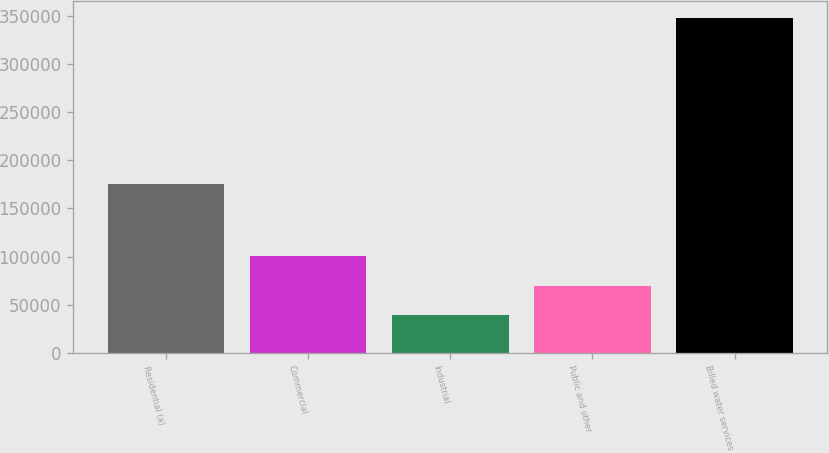<chart> <loc_0><loc_0><loc_500><loc_500><bar_chart><fcel>Residential (a)<fcel>Commercial<fcel>Industrial<fcel>Public and other<fcel>Billed water services<nl><fcel>175653<fcel>100741<fcel>38991<fcel>69865.9<fcel>347740<nl></chart> 